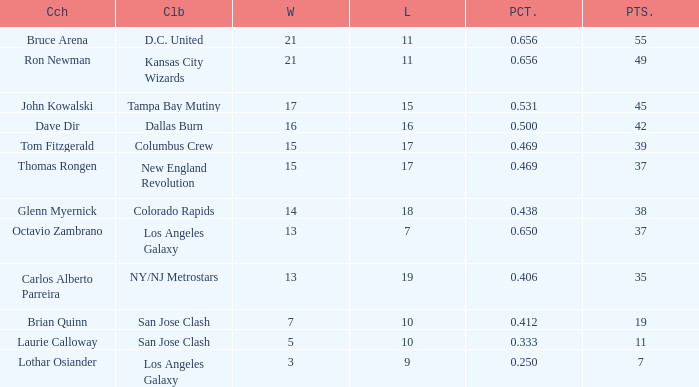What is the highest percent of Bruce Arena when he loses more than 11 games? None. 